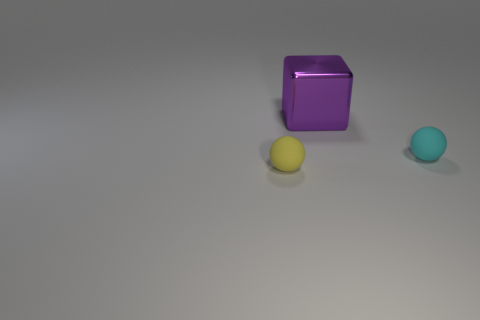Subtract all cyan blocks. Subtract all gray cylinders. How many blocks are left? 1 Add 1 green shiny balls. How many objects exist? 4 Subtract all spheres. How many objects are left? 1 Subtract 0 blue cylinders. How many objects are left? 3 Subtract all cyan matte things. Subtract all small purple rubber things. How many objects are left? 2 Add 1 yellow rubber objects. How many yellow rubber objects are left? 2 Add 1 small purple cylinders. How many small purple cylinders exist? 1 